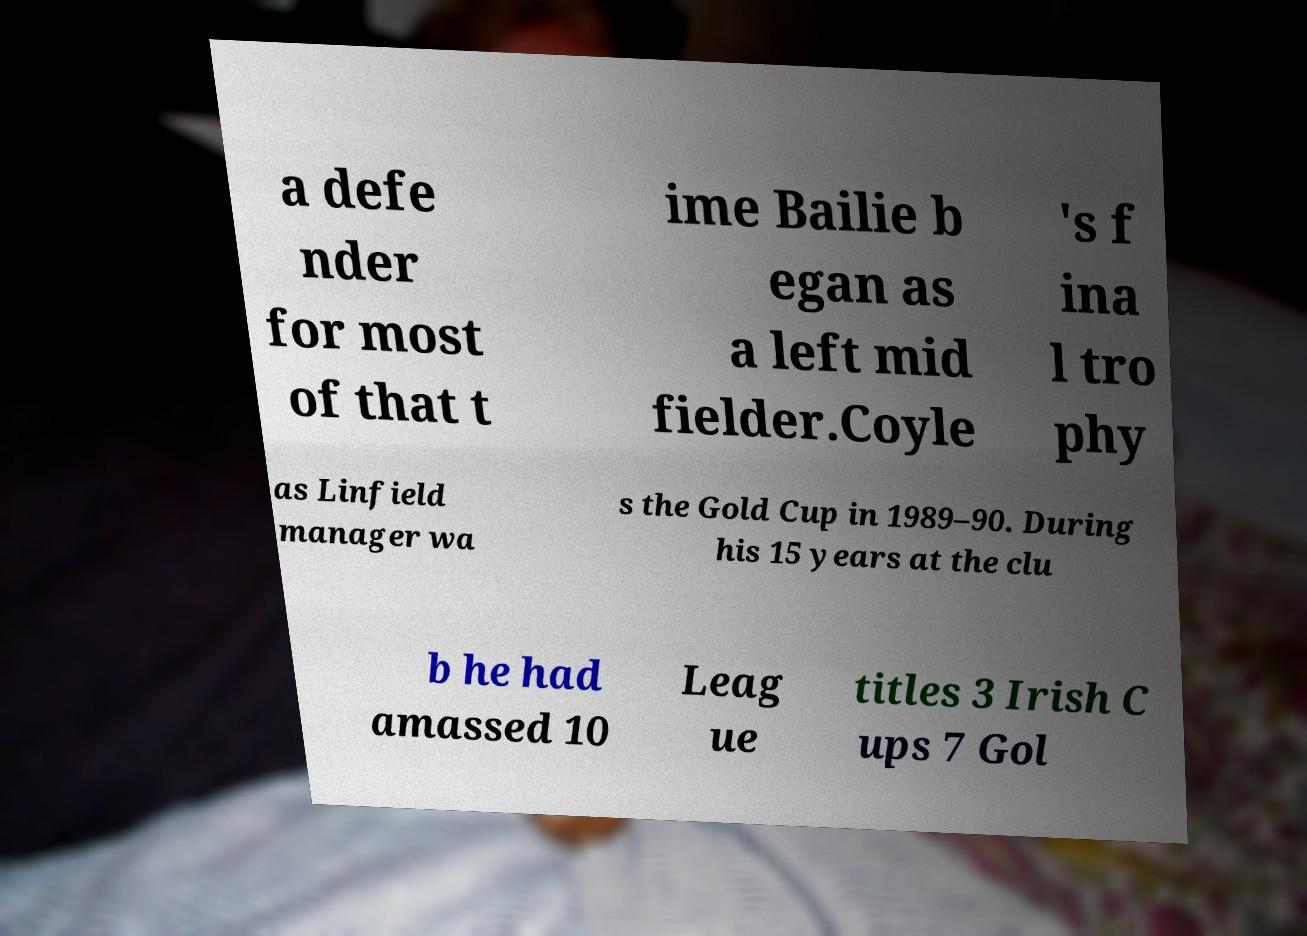Please identify and transcribe the text found in this image. a defe nder for most of that t ime Bailie b egan as a left mid fielder.Coyle 's f ina l tro phy as Linfield manager wa s the Gold Cup in 1989–90. During his 15 years at the clu b he had amassed 10 Leag ue titles 3 Irish C ups 7 Gol 